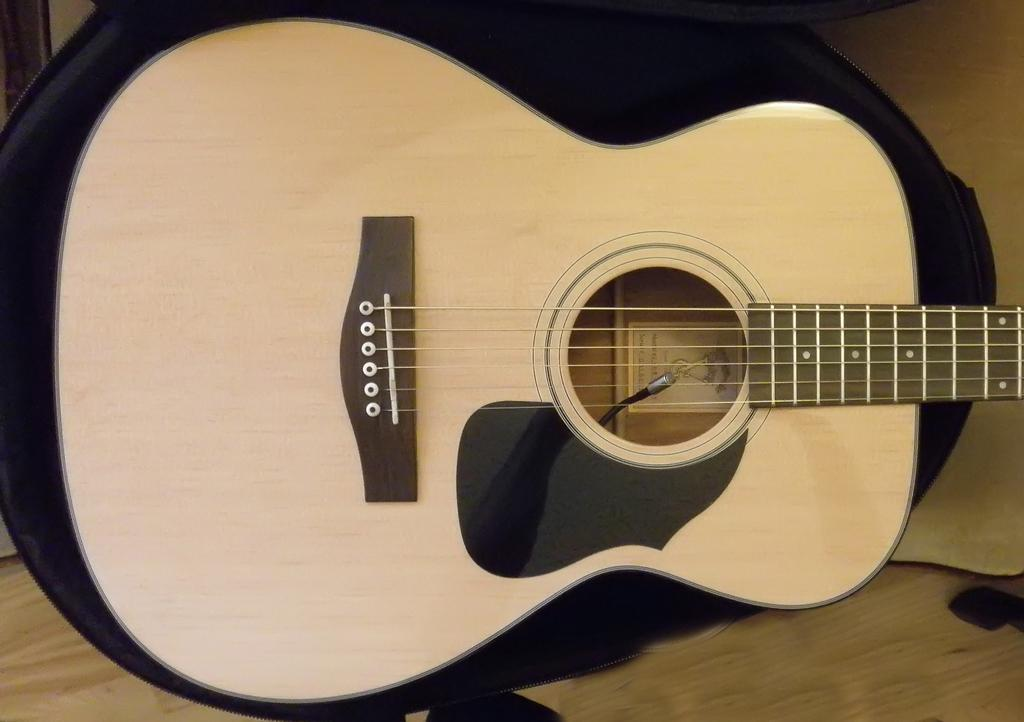What musical instrument is present in the image? There is a guitar in the image. What type of flooring can be seen in the image? There is a wooden floor in the image. What type of office furniture is present in the image? There is no office furniture present in the image; it only features a guitar and a wooden floor. Is there any indication of a landmark or specific location in the image? The image does not provide any information about a landmark or specific location; it only shows a guitar and a wooden floor. 